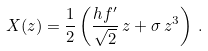<formula> <loc_0><loc_0><loc_500><loc_500>X ( z ) = \frac { 1 } { 2 } \left ( \frac { h f ^ { \prime } } { \sqrt { 2 } } \, z + \sigma \, z ^ { 3 } \right ) \, .</formula> 